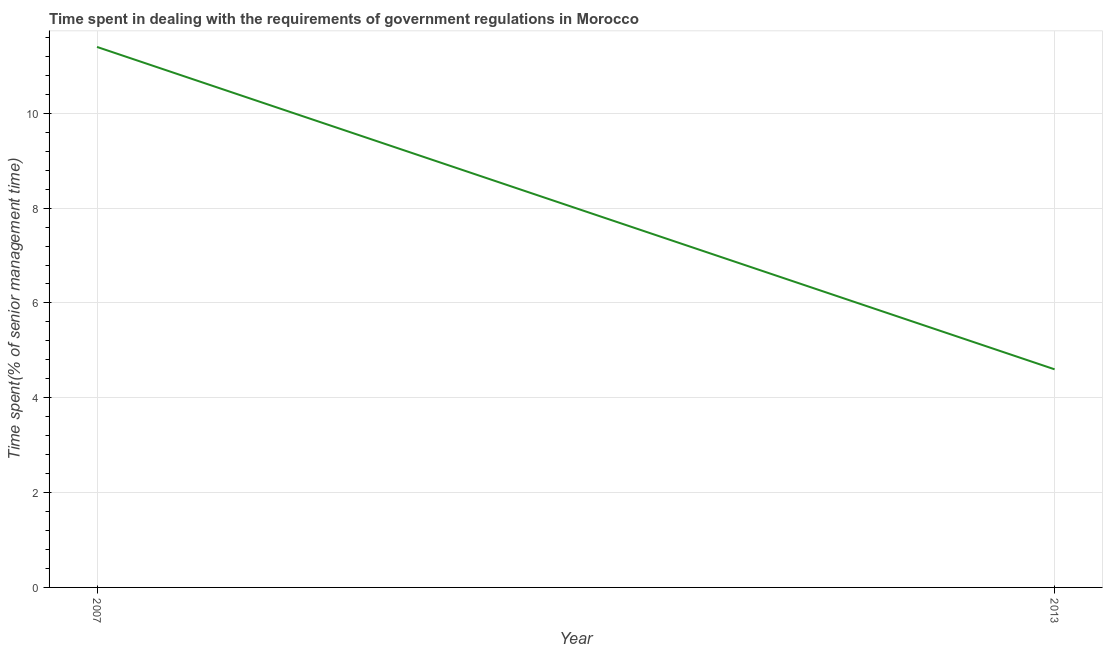What is the time spent in dealing with government regulations in 2013?
Your answer should be compact. 4.6. Across all years, what is the minimum time spent in dealing with government regulations?
Make the answer very short. 4.6. In which year was the time spent in dealing with government regulations maximum?
Keep it short and to the point. 2007. In which year was the time spent in dealing with government regulations minimum?
Make the answer very short. 2013. What is the difference between the time spent in dealing with government regulations in 2007 and 2013?
Your response must be concise. 6.8. Do a majority of the years between 2013 and 2007 (inclusive) have time spent in dealing with government regulations greater than 1.6 %?
Your response must be concise. No. What is the ratio of the time spent in dealing with government regulations in 2007 to that in 2013?
Your answer should be very brief. 2.48. In how many years, is the time spent in dealing with government regulations greater than the average time spent in dealing with government regulations taken over all years?
Make the answer very short. 1. Does the time spent in dealing with government regulations monotonically increase over the years?
Give a very brief answer. No. How many years are there in the graph?
Your answer should be compact. 2. What is the difference between two consecutive major ticks on the Y-axis?
Ensure brevity in your answer.  2. Are the values on the major ticks of Y-axis written in scientific E-notation?
Your answer should be very brief. No. Does the graph contain grids?
Provide a short and direct response. Yes. What is the title of the graph?
Ensure brevity in your answer.  Time spent in dealing with the requirements of government regulations in Morocco. What is the label or title of the X-axis?
Keep it short and to the point. Year. What is the label or title of the Y-axis?
Offer a very short reply. Time spent(% of senior management time). What is the Time spent(% of senior management time) in 2013?
Provide a succinct answer. 4.6. What is the difference between the Time spent(% of senior management time) in 2007 and 2013?
Your response must be concise. 6.8. What is the ratio of the Time spent(% of senior management time) in 2007 to that in 2013?
Offer a very short reply. 2.48. 